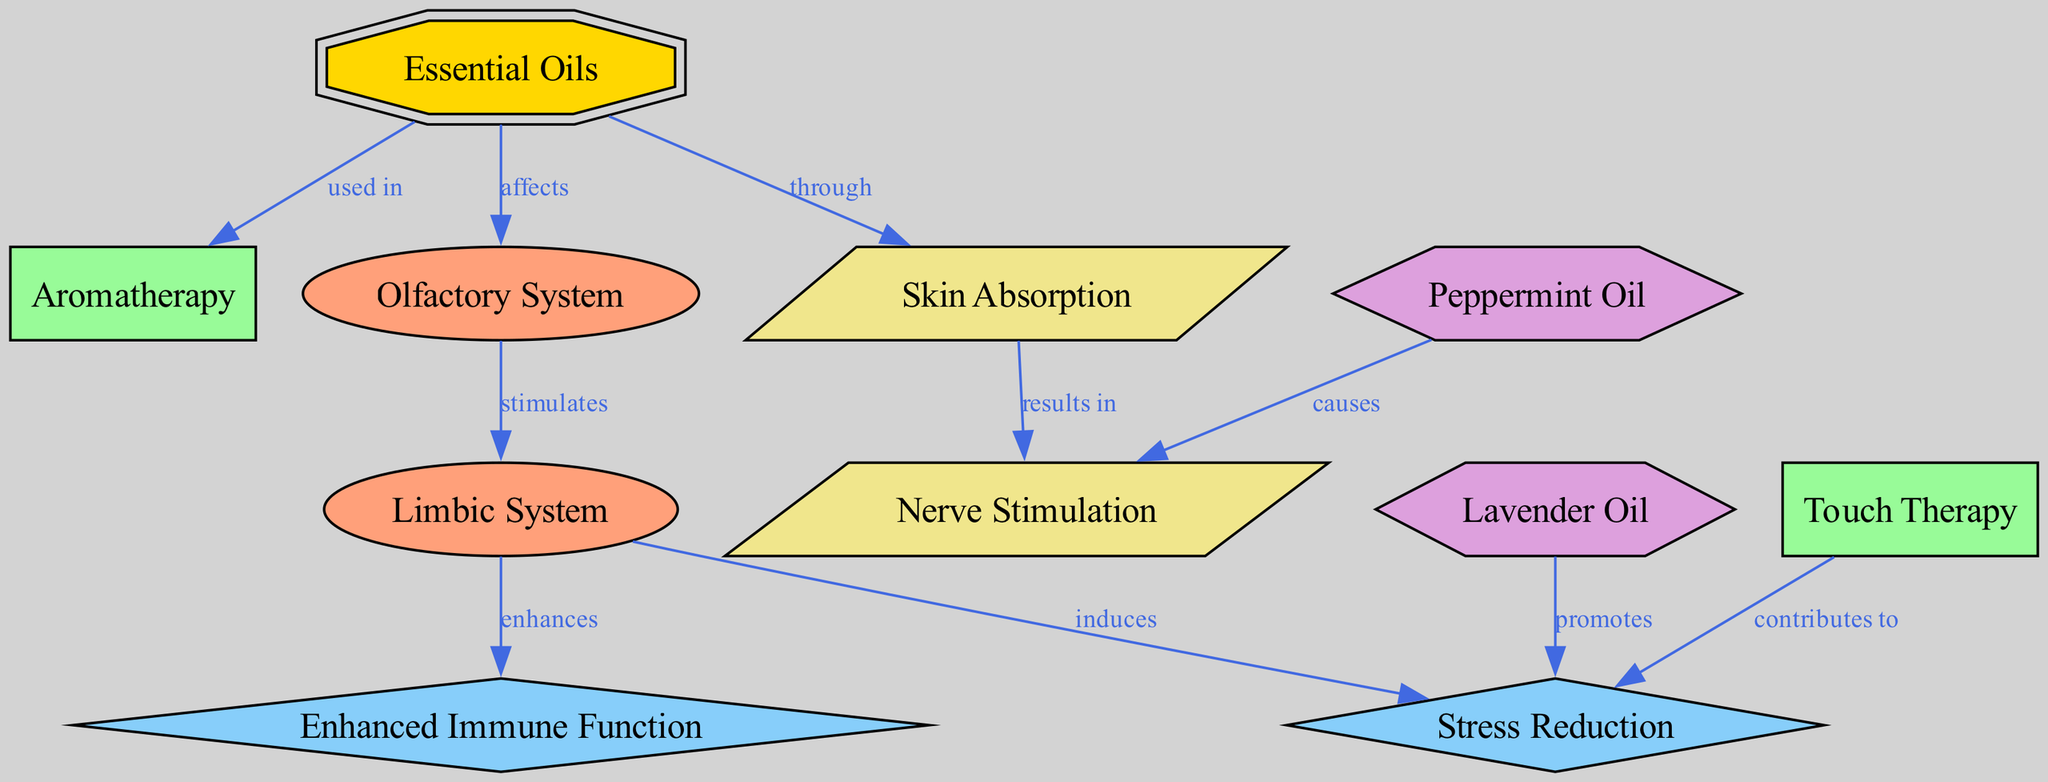What are the two essential oils mentioned in the diagram? The diagram lists "Lavender Oil" and "Peppermint Oil" as the two essential oils. This information can be found directly under the "essential_oil" nodes in the diagram.
Answer: Lavender Oil, Peppermint Oil Which physiological effect is induced by the limbic system? According to the diagram, the limbic system induces "Stress Reduction." This connection is represented as an arrow moving from the "limbic system" node to the "stress reduction" node.
Answer: Stress Reduction How many nodes are classified as essential oils in the diagram? The diagram contains two nodes labeled as essential oils: "Lavender Oil" and "Peppermint Oil," making a total of two. This is derived from counting the nodes of type "essential_oil."
Answer: 2 What mechanism results from skin absorption? The mechanism of "nerve stimulation" results from "skin absorption" as indicated by the arrow moving from the "skin absorption" node to the "nerve stimulation" node, showing a direct relationship.
Answer: Nerve Stimulation What practice contributes to stress reduction? The diagram shows that "Touch Therapy" contributes to "Stress Reduction." This relationship is depicted with an arrow from the "touch therapy" node to the "stress reduction" node.
Answer: Touch Therapy Which system is stimulated by the olfactory system? The olfactory system stimulates the "Limbic System" as per the arrow in the diagram indicating a direct interaction between these two nodes.
Answer: Limbic System What does lavender oil promote? Lavender oil promotes "Stress Reduction," which is explicitly stated in the diagram with a direct arrow connecting these two nodes.
Answer: Stress Reduction Which physiological effect does the limbic system enhance? The limbic system enhances "Immune Function," as shown by the connection between the "limbic system" node and the "immune function" node in the diagram.
Answer: Immune Function How do essential oils affect the human body according to the diagram? Essential oils affect the olfactory system, which in turn stimulates the limbic system, leading to various physiological effects like stress reduction and enhanced immune function. This flow is visually represented through multiple arrows showing interaction among these nodes.
Answer: Affects olfactory system 